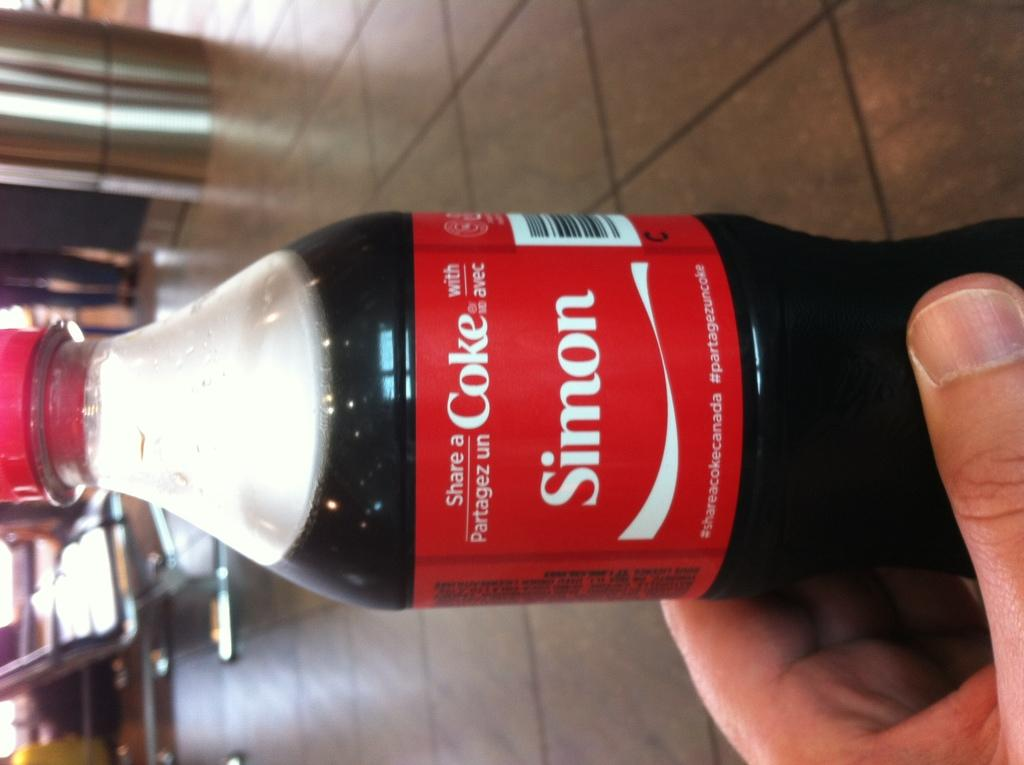<image>
Present a compact description of the photo's key features. A bottle of coke has the phrase, share a coke with Simon. 